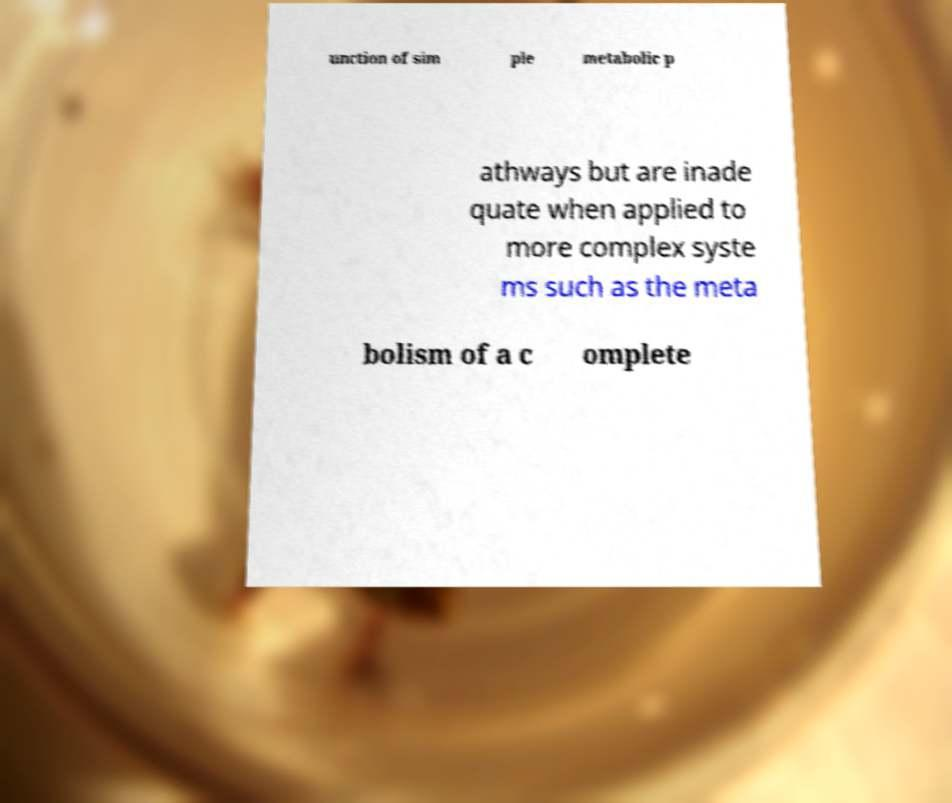For documentation purposes, I need the text within this image transcribed. Could you provide that? unction of sim ple metabolic p athways but are inade quate when applied to more complex syste ms such as the meta bolism of a c omplete 